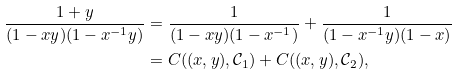Convert formula to latex. <formula><loc_0><loc_0><loc_500><loc_500>\frac { 1 + y } { ( 1 - x y ) ( 1 - x ^ { - 1 } y ) } & = \frac { 1 } { ( 1 - x y ) ( 1 - x ^ { - 1 } ) } + \frac { 1 } { ( 1 - x ^ { - 1 } y ) ( 1 - x ) } \\ & = C ( ( x , y ) , \mathcal { C } _ { 1 } ) + C ( ( x , y ) , \mathcal { C } _ { 2 } ) ,</formula> 